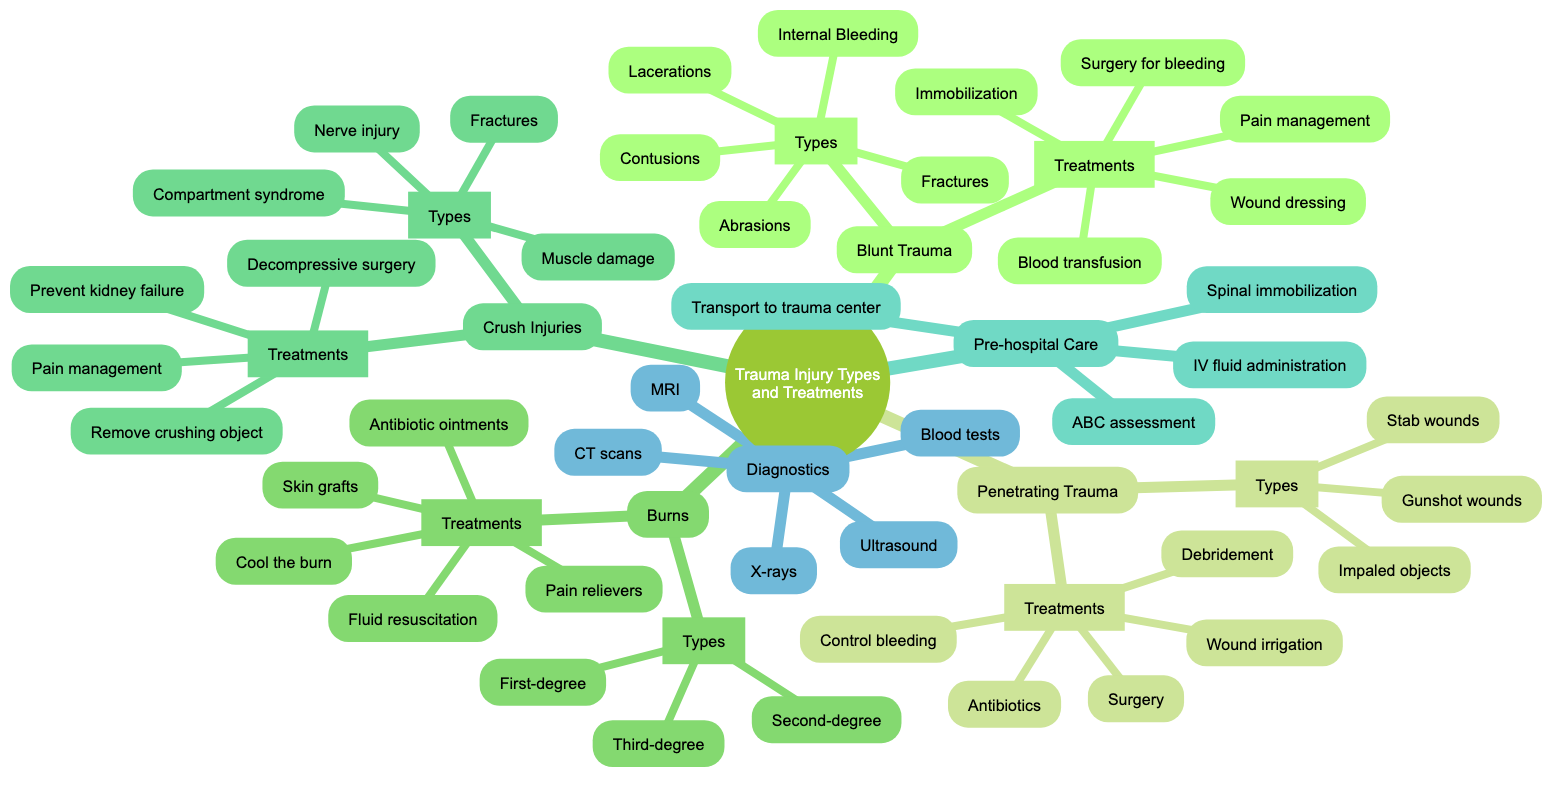What are the three types of Burns mentioned? The diagram lists three types of burns: First-degree burns, Second-degree burns, and Third-degree burns under the Burns subtopic.
Answer: First-degree burns, Second-degree burns, Third-degree burns How many types of Blunt Trauma are there? Under the Blunt Trauma subtopic, there are five types of injuries listed: Contusions, Abrasions, Lacerations, Fractures, and Internal Bleeding.
Answer: 5 Which treatment is common for both Blunt Trauma and Crush Injuries? By examining the treatments for Blunt Trauma and Crush Injuries, both include Pain management, indicating this treatment is applicable for both injury types.
Answer: Pain management What is the first step in Pre-hospital Care according to the diagram? The Pre-hospital Care section starts with the ABC assessment, which is the first step listed to address trauma care effectively.
Answer: ABC assessment How many treatments are specified for Penetrating Trauma? The diagram outlines five treatments under the Penetrating Trauma section: Control bleeding, Wound irrigation, Debridement, Antibiotics, and Surgery for repair and removal of objects, summing up to five.
Answer: 5 What type of diagnostic imaging is used before surgical intervention in trauma cases? The diagram lists several diagnostic types, including CT scans, which are commonly used prior to surgical intervention to assess trauma.
Answer: CT scans What are the two main categories of trauma injuries identified in the diagram? The conceptual map divides trauma injuries into two main categories: Blunt Trauma and Penetrating Trauma, covering the primary mechanisms of injury.
Answer: Blunt Trauma and Penetrating Trauma What treatment is specific to Crush Injuries? Among the treatments listed under Crush Injuries, Decompressive surgery is specifically mentioned, and it addresses the unique needs associated with this severe injury type.
Answer: Decompressive surgery 